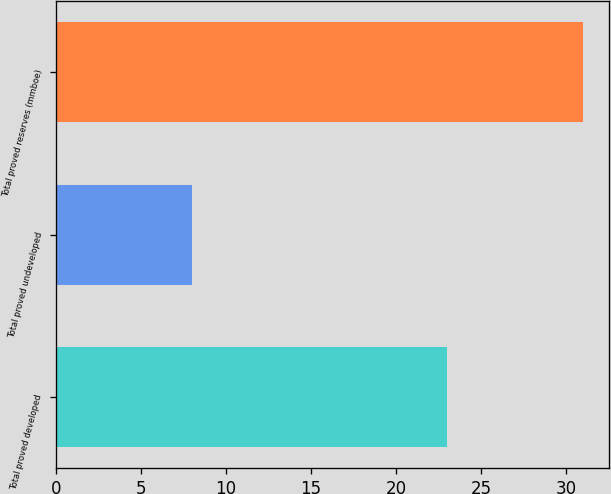Convert chart. <chart><loc_0><loc_0><loc_500><loc_500><bar_chart><fcel>Total proved developed<fcel>Total proved undeveloped<fcel>Total proved reserves (mmboe)<nl><fcel>23<fcel>8<fcel>31<nl></chart> 